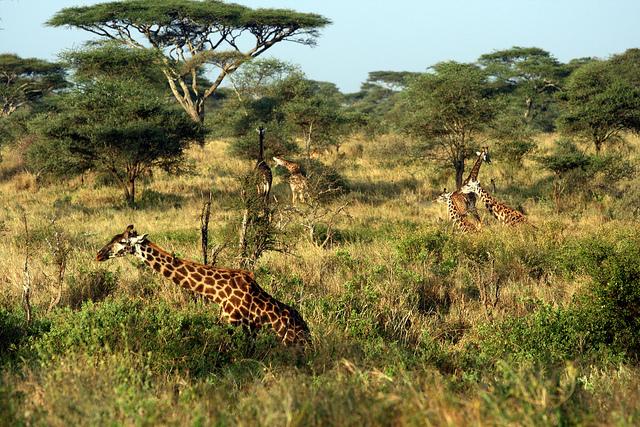Are the giraffes in the wild?
Short answer required. Yes. What is the tallest object in the photo?
Quick response, please. Tree. How many giraffes are there?
Quick response, please. 3. 